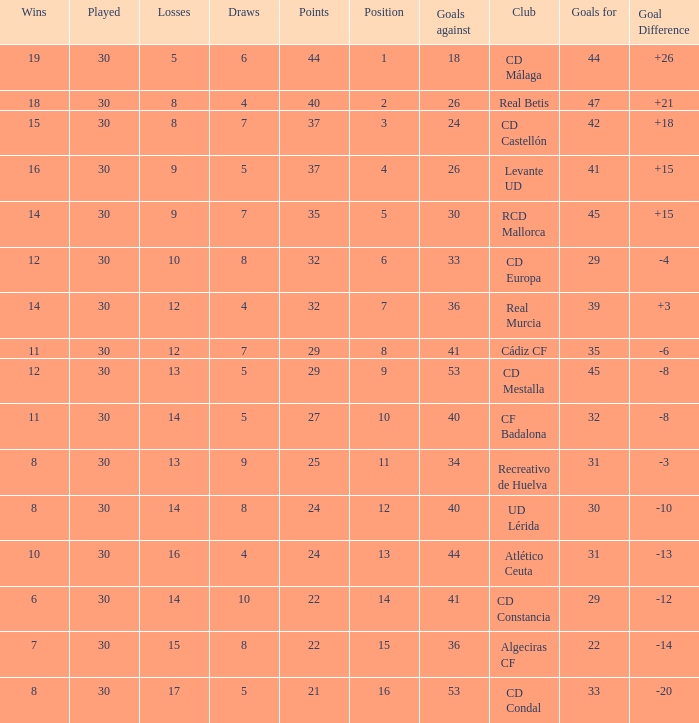What is the number of draws when played is smaller than 30? 0.0. 